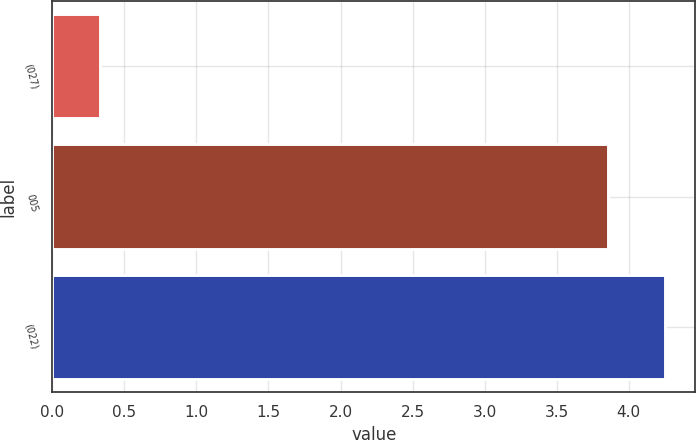<chart> <loc_0><loc_0><loc_500><loc_500><bar_chart><fcel>(027)<fcel>005<fcel>(022)<nl><fcel>0.33<fcel>3.86<fcel>4.25<nl></chart> 